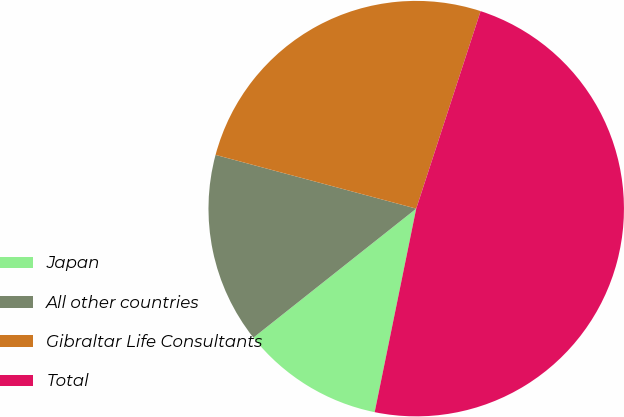Convert chart. <chart><loc_0><loc_0><loc_500><loc_500><pie_chart><fcel>Japan<fcel>All other countries<fcel>Gibraltar Life Consultants<fcel>Total<nl><fcel>11.13%<fcel>14.83%<fcel>25.85%<fcel>48.19%<nl></chart> 